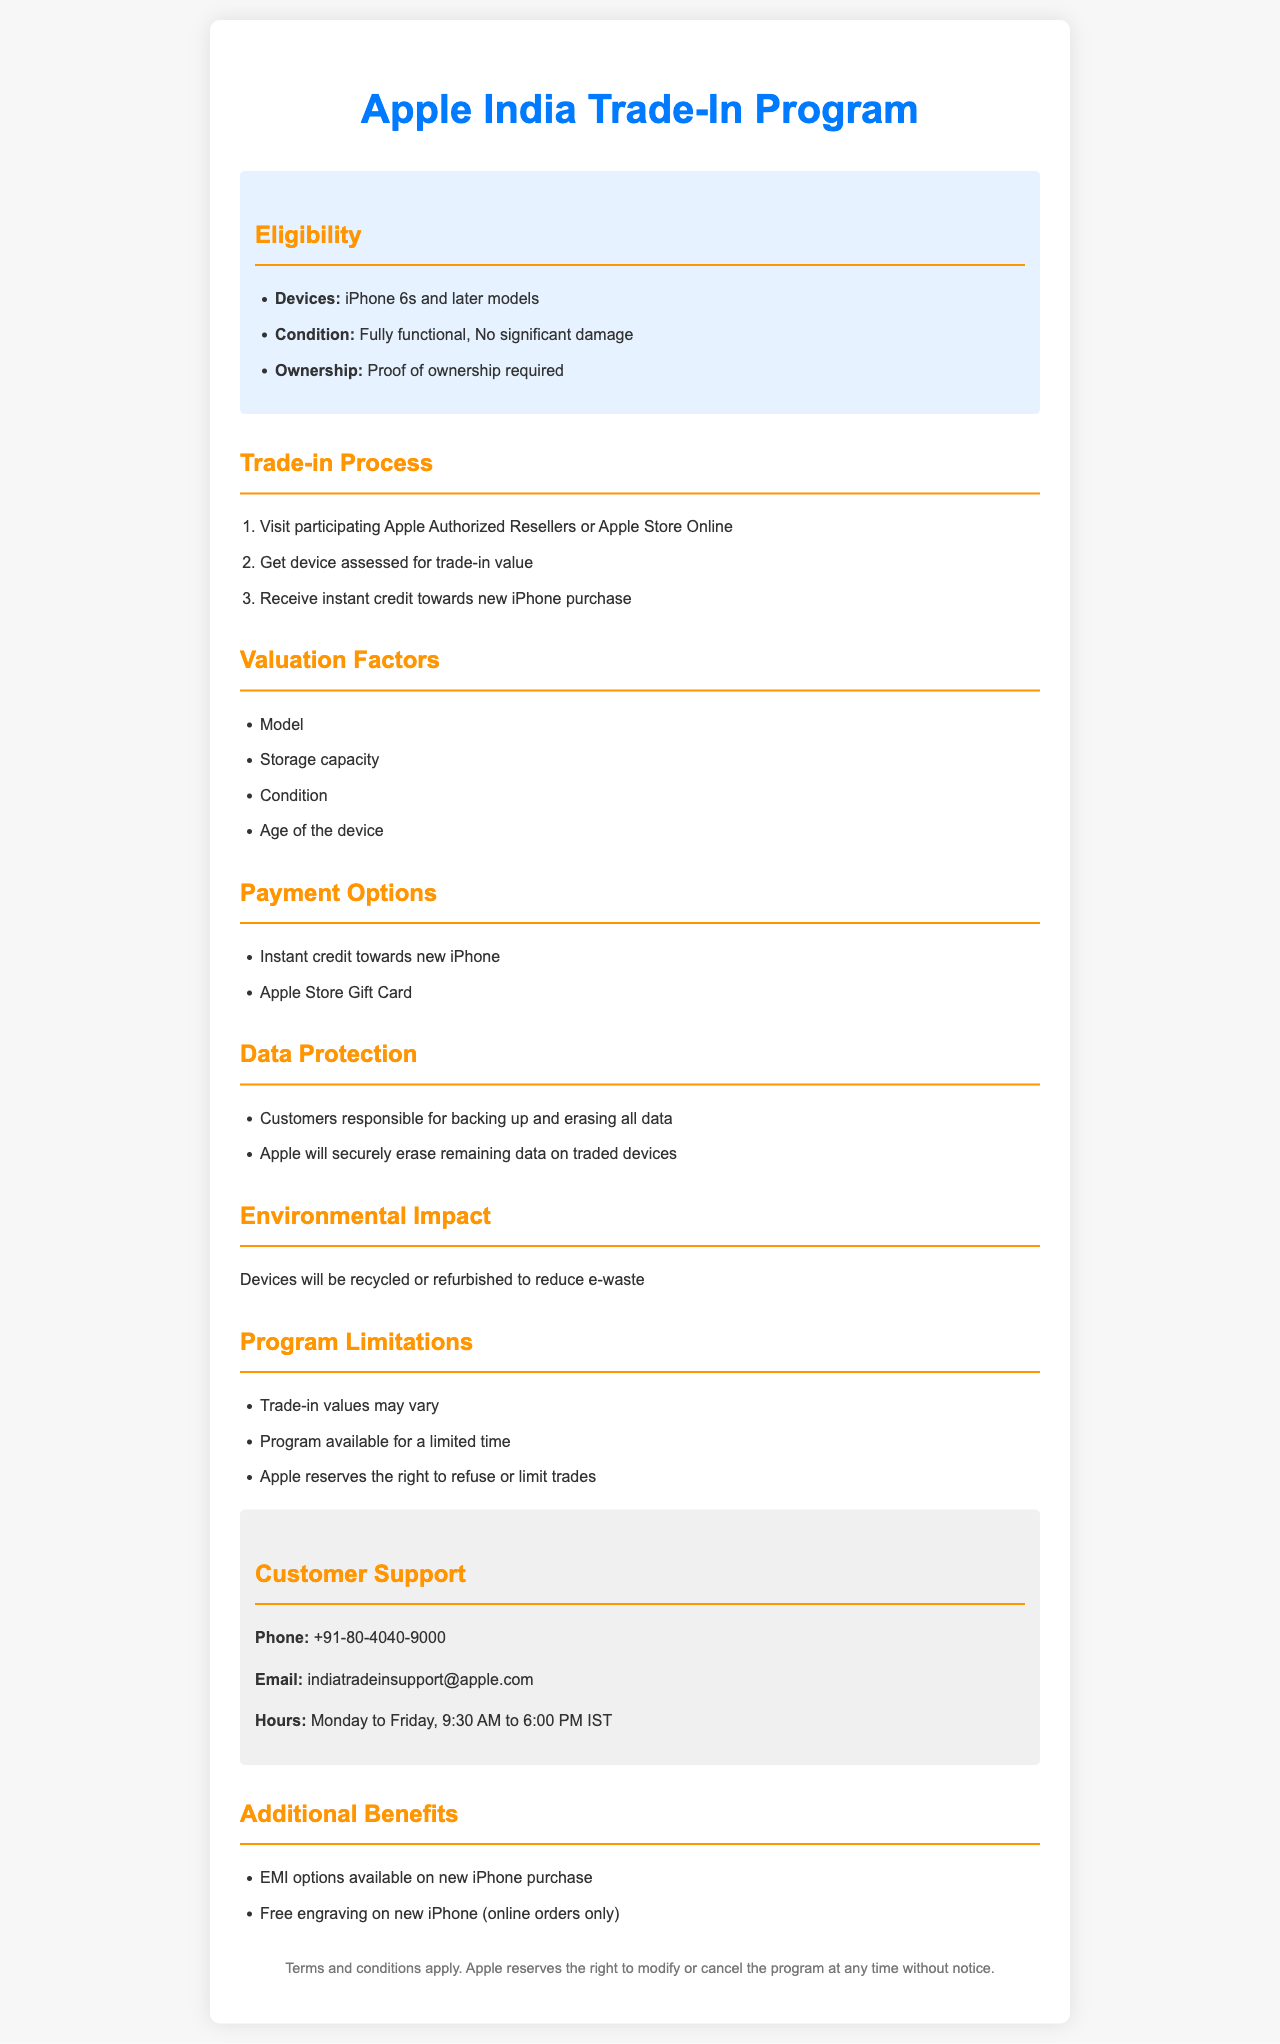What devices are eligible for trade-in? The eligible devices for trade-in are specified in the document.
Answer: iPhone 6s and later models What is required to prove ownership? The document mentions a requirement related to ownership proof.
Answer: Proof of ownership required What factors influence the trade-in valuation? Multiple factors are listed in the valuation section of the document.
Answer: Model, Storage capacity, Condition, Age of the device What payment options are available in the program? The document outlines the available payment options for consumers.
Answer: Instant credit towards new iPhone, Apple Store Gift Card What is the customer support phone number? The document provides a contact option for customer support.
Answer: +91-80-4040-9000 What are customers responsible for before trading in their devices? The data protection section specifies customer actions before trade-in.
Answer: Backing up and erasing all data Why does Apple recycle or refurbish devices? The environmental impact section explains the reason for recycling.
Answer: To reduce e-waste What additional benefit is provided for new iPhone purchases? The document lists additional benefits related to iPhone purchases.
Answer: EMI options available on new iPhone purchase 